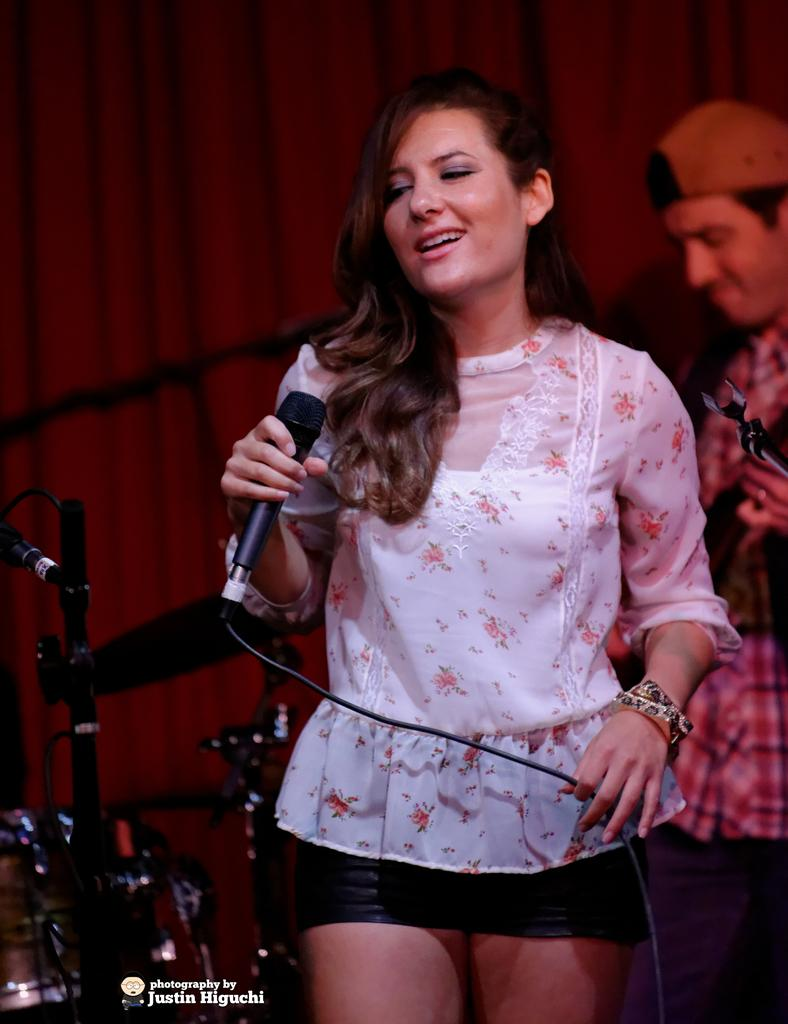What is the gender of the person in the image? There is a woman in the image. What is the woman doing in the image? The woman is standing and holding a microphone in her hand. What is the woman's facial expression in the image? The woman is smiling in the image. Is there anyone else in the image besides the woman? Yes, there is a man in the image. Where is the man positioned in relation to the woman? The man is standing behind the woman. What type of bean is being used as a prop in the image? There is no bean present in the image; it features a woman holding a microphone and standing with a man behind her. 